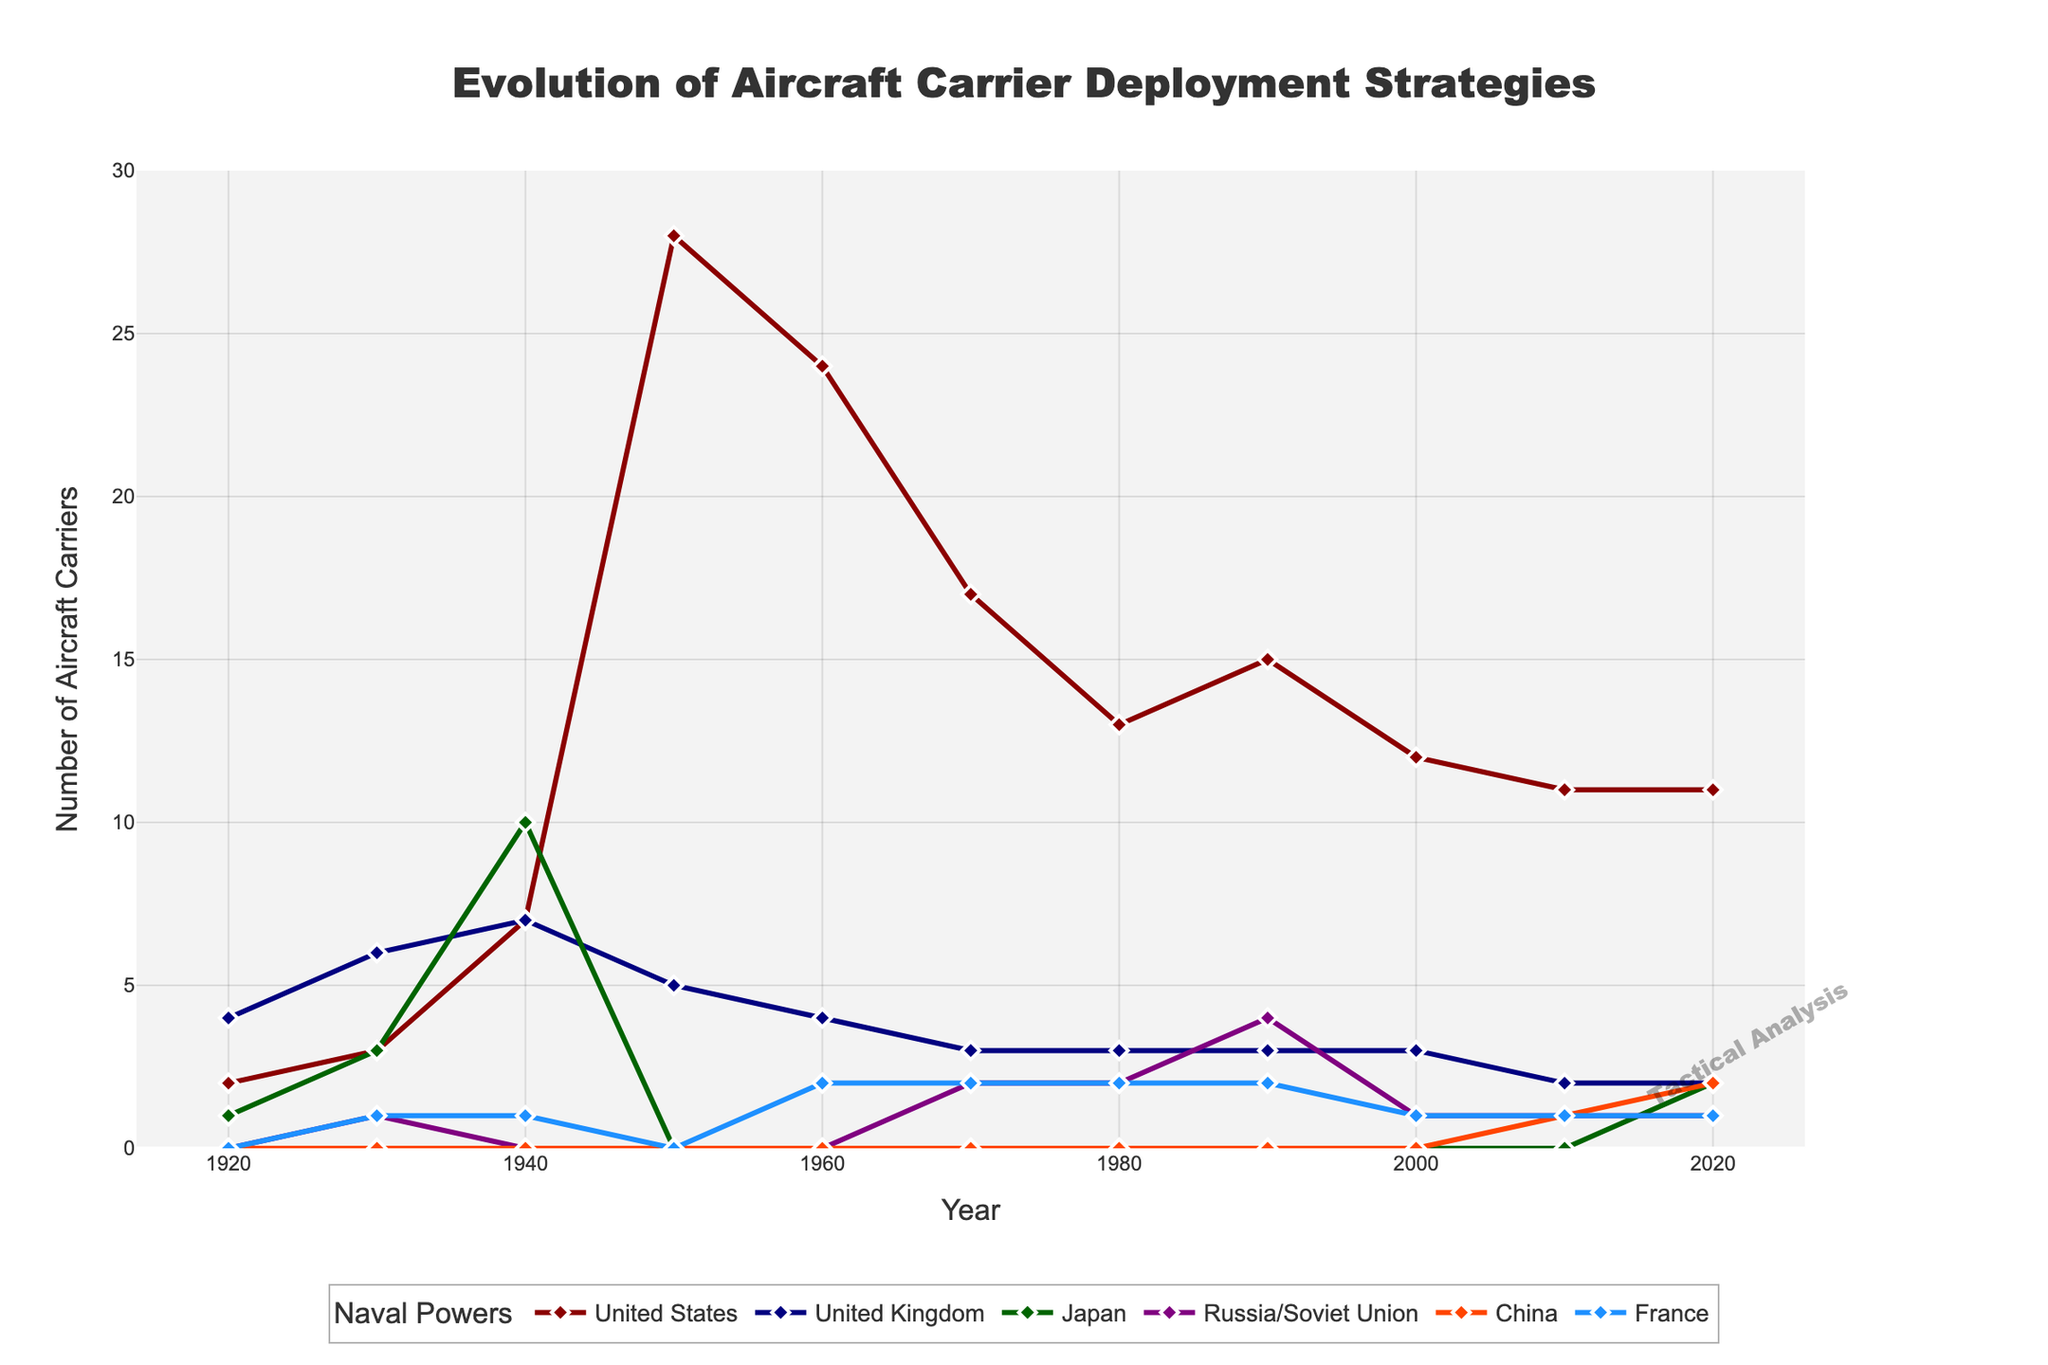Which country had the highest number of aircraft carriers in 1950? The line for the United States is at the highest point in 1950 with 28 aircraft carriers.
Answer: United States By how much did the number of aircraft carriers for Japan decrease between 1940 and 1950? The number of aircraft carriers for Japan in 1940 was 10, and in 1950 it was 0. The decrease is 10 - 0 = 10.
Answer: 10 Which countries had an increase in the number of aircraft carriers from 2010 to 2020? From the graph, China increased from 1 to 2 and Japan from 0 to 2 between 2010 and 2020.
Answer: China and Japan In which decade did Russia/Soviet Union first deploy aircraft carriers according to the graph? Russia/Soviet Union is first shown deploying aircraft carriers in 1970 according to the line chart.
Answer: 1970s What is the total number of aircraft carriers deployed by the United Kingdom across all the years displayed? Sum all the data points for the United Kingdom: 4 + 6 + 7 + 5 + 4 + 3 + 3 + 3 + 3 + 2 + 2 = 42.
Answer: 42 Compare the number of aircraft carriers for China and France in 1980. Which country had more and by how many? In 1980, China had 0 aircraft carriers, and France had 2. France had 2 more than China (2 - 0 = 2).
Answer: France, by 2 During which decade did the United States see the largest decrease in the number of aircraft carriers? The largest decrease for the United States is from 1950 (28) to 1960 (24), a decrease of 4.
Answer: 1950-1960 What is the maximum number of aircraft carriers deployed at any given year during the period covered by the data, and which country reached this maximum? The maximum number is 28, reached by the United States in 1950 according to the graph.
Answer: 28, United States In 2020, how does the number of aircraft carriers deployed by China compare to that deployed by Russia/Soviet Union? In 2020, China had 2 aircraft carriers, and Russia had 1. China had 1 more than Russia.
Answer: China, 1 more What is the average number of aircraft carriers deployed by the United States from 1920 to 2020? Summing the data points: 2 + 3 + 7 + 28 + 24 + 17 + 13 + 15 + 12 + 11 + 11 = 143. There are 11 data points. Average = 143 / 11 ≈ 13.
Answer: 13 